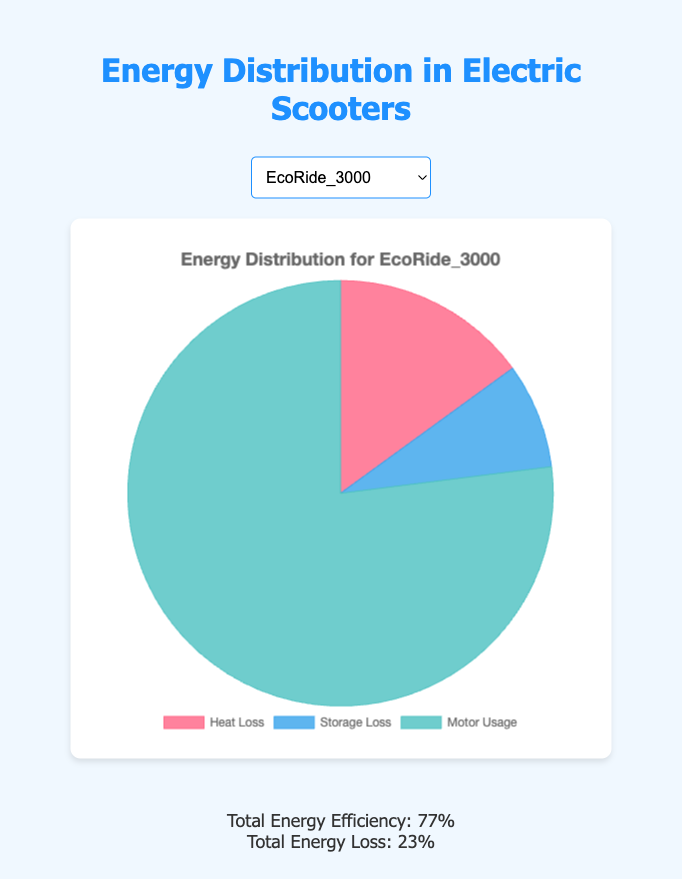Which scooter model has the highest proportion of energy used by the motor? To determine which scooter model has the highest proportion of energy used by the motor, we need to compare the 'Motor Usage' percentages: EcoRide_3000 (77%), UrbanCruise_450 (78%), Speedster_700 (72%), EcoRide_500 (79%), and CityCommuter_200 (76%). EcoRide_500 has the highest at 79%.
Answer: EcoRide_500 Which scooter model loses the least energy in storage losses? To identify the scooter model with the least storage losses, we compare the 'Storage Loss' values: EcoRide_3000 (8%), UrbanCruise_450 (12%), Speedster_700 (10%), EcoRide_500 (9%), and CityCommuter_200 (11%). The EcoRide_3000 has the lowest storage loss at 8%.
Answer: EcoRide_3000 What is the combined energy loss percentage for EcoRide_3000 from heat and storage? To find the combined energy loss percentage, sum the 'Heat Loss' and 'Storage Loss' for EcoRide_3000: 15% (Heat Loss) + 8% (Storage Loss) = 23%.
Answer: 23% Which scooter model has the lowest total energy loss? We need to sum the 'Heat Loss' and 'Storage Loss' for each model and identify the smallest sum: EcoRide_3000 (15% + 8% = 23%), UrbanCruise_450 (10% + 12% = 22%), Speedster_700 (18% + 10% = 28%), EcoRide_500 (12% + 9% = 21%), CityCommuter_200 (13% + 11% = 24%). EcoRide_500 has the lowest total energy loss at 21%.
Answer: EcoRide_500 What is the average proportion of motor usage across all scooter models? To calculate the average proportion of motor usage, sum the 'Motor Usage' values and divide by the number of models: (77% + 78% + 72% + 79% + 76%) / 5 = 76.4%.
Answer: 76.4% By how much does the heat loss of Speedster_700 exceed that of UrbanCruise_450? Subtract the 'Heat Loss' of UrbanCruise_450 from Speedster_700: 18% (Speedster_700) - 10% (UrbanCruise_450) = 8%.
Answer: 8% Which model has the smallest difference between motor usage and heat loss? Calculate the difference between 'Motor Usage' and 'Heat Loss' for each model and identify the smallest difference: EcoRide_3000 (77% - 15% = 62%), UrbanCruise_450 (78% - 10% = 68%), Speedster_700 (72% - 18% = 54%), EcoRide_500 (79% - 12% = 67%), CityCommuter_200 (76% - 13% = 63%). Speedster_700 has the smallest difference at 54%.
Answer: Speedster_700 What visual attribute distinguishes the motor usage section in the pie chart across all models? The motor usage section in the pie chart for all models is represented by a distinct light blue color, making it visually identifiable.
Answer: light blue 